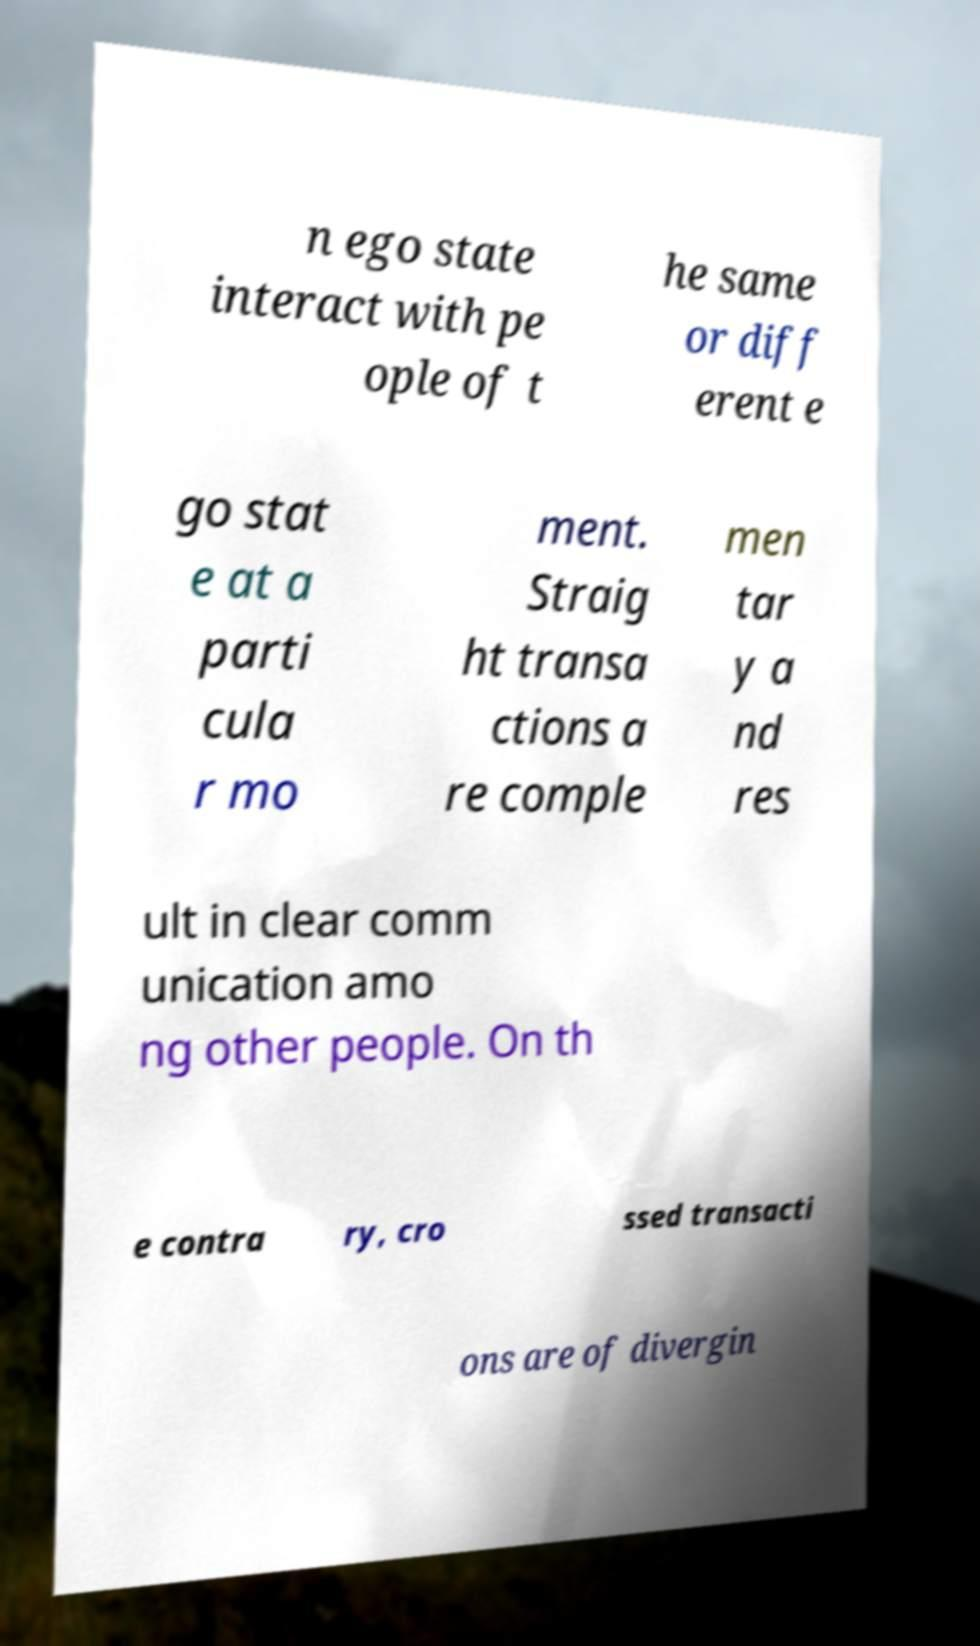Could you extract and type out the text from this image? n ego state interact with pe ople of t he same or diff erent e go stat e at a parti cula r mo ment. Straig ht transa ctions a re comple men tar y a nd res ult in clear comm unication amo ng other people. On th e contra ry, cro ssed transacti ons are of divergin 